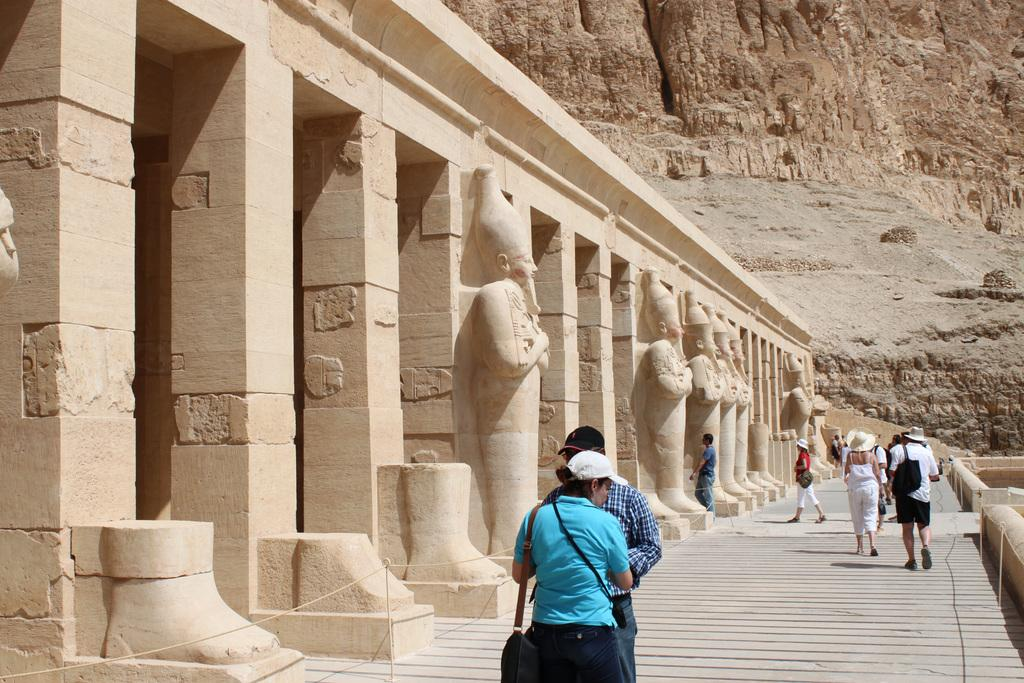How many people are visible in the image? There are many people in the image. What type of location does the image appear to depict? The image appears to depict a historic place. What architectural features can be seen in the front of the image? There are pillars and sculptures in the front of the image. What natural feature is visible on the right side of the image? There is a mountain on the right side of the image. What color is the shirt worn by the jellyfish in the image? There are no jellyfish present in the image; it depicts a historic place with people, pillars, sculptures, and a mountain. 